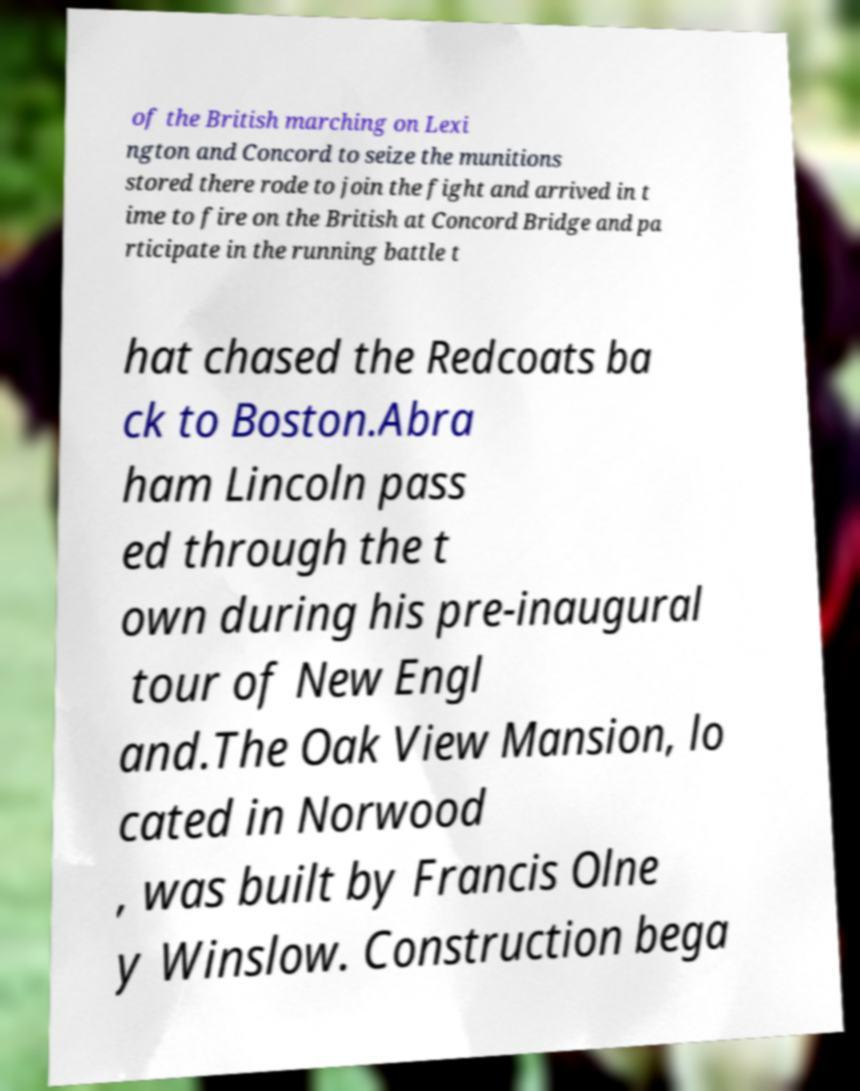I need the written content from this picture converted into text. Can you do that? of the British marching on Lexi ngton and Concord to seize the munitions stored there rode to join the fight and arrived in t ime to fire on the British at Concord Bridge and pa rticipate in the running battle t hat chased the Redcoats ba ck to Boston.Abra ham Lincoln pass ed through the t own during his pre-inaugural tour of New Engl and.The Oak View Mansion, lo cated in Norwood , was built by Francis Olne y Winslow. Construction bega 